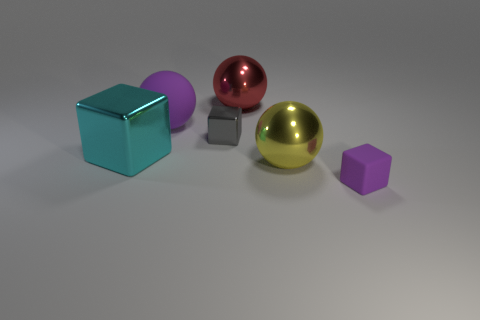Subtract all green balls. Subtract all green cylinders. How many balls are left? 3 Add 3 large purple matte things. How many objects exist? 9 Add 2 yellow balls. How many yellow balls are left? 3 Add 6 big purple objects. How many big purple objects exist? 7 Subtract 0 brown cylinders. How many objects are left? 6 Subtract all small rubber blocks. Subtract all tiny red blocks. How many objects are left? 5 